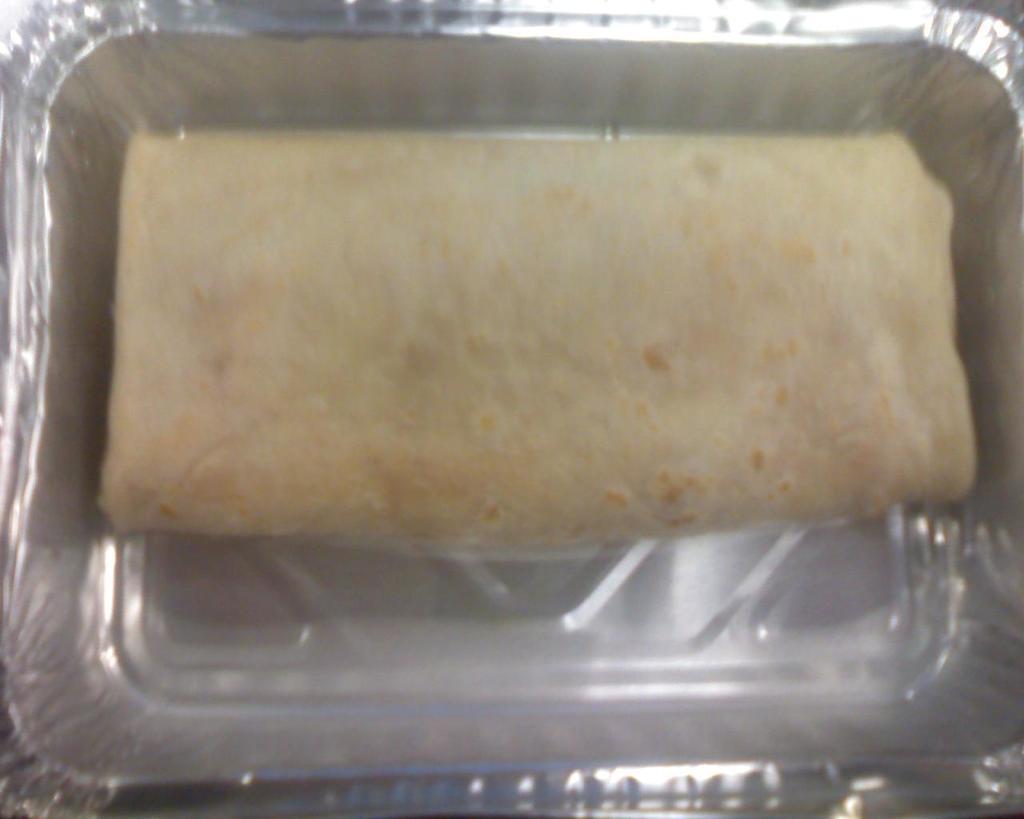Please provide a concise description of this image. In this image we can see a food item in a silver color box. 